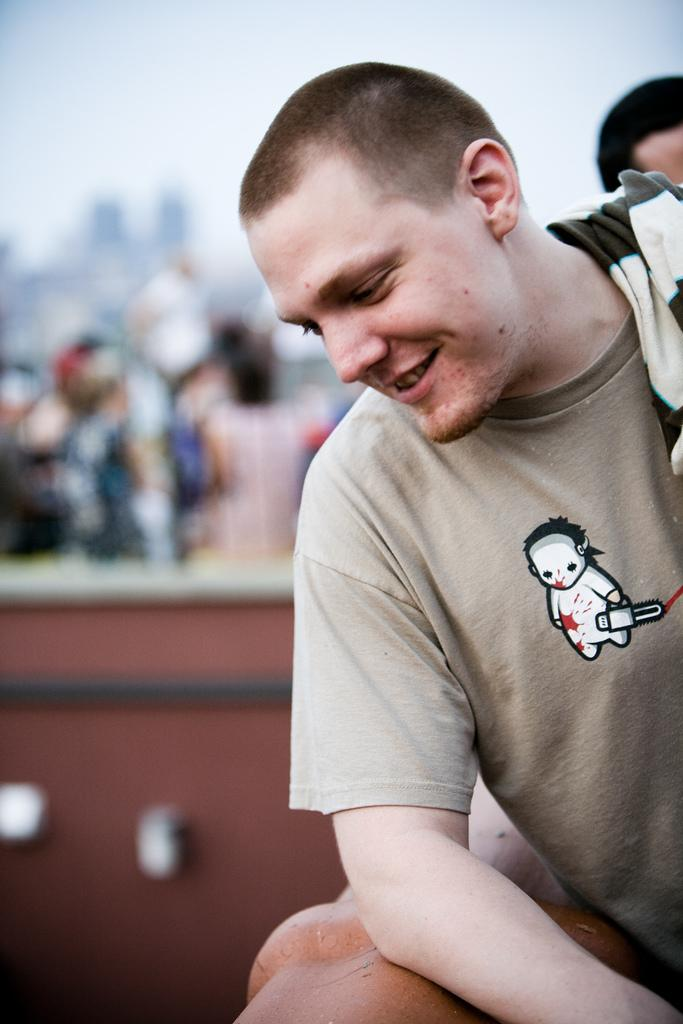Who is present in the image? There is a man in the image. What is the man's facial expression? The man is smiling. What can be seen in the background of the image? There are people and a wall in the background of the image. What type of cushion is the man sitting on in the image? There is no cushion present in the image, and the man is not sitting down. 